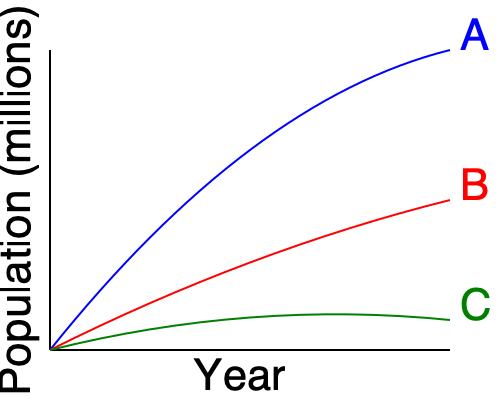The graph shows population growth curves for three different religious denominations (A, B, and C) over time. Which denomination is likely experiencing the most rapid decline in new converts or young members? To answer this question, we need to analyze the growth patterns of each denomination:

1. Denomination A (blue curve):
   - Shows rapid growth initially
   - Growth rate slows down over time but remains positive
   - Indicates a healthy, growing population

2. Denomination B (red curve):
   - Demonstrates moderate, steady growth
   - Growth rate is slower than A but consistent
   - Suggests a stable population with steady increase

3. Denomination C (green curve):
   - Initially shows slow growth
   - Growth rate decreases over time
   - Curve begins to flatten towards the end
   - Indicates a population that is growing very slowly or stagnating

The denomination experiencing the most rapid decline in new converts or young members would be the one with the flattest or most downward-trending curve. In this case, Denomination C (green curve) shows the least growth and is beginning to flatten, suggesting it is struggling to attract new members or retain younger ones.

This pattern could be due to various factors such as:
- Aging congregation
- Difficulty in attracting younger generations
- Decreasing birth rates within the denomination
- Increased secularization in society

While Denominations A and B are still growing, C's flattening curve suggests it is the most likely to be experiencing a decline in new converts or young members.
Answer: Denomination C 